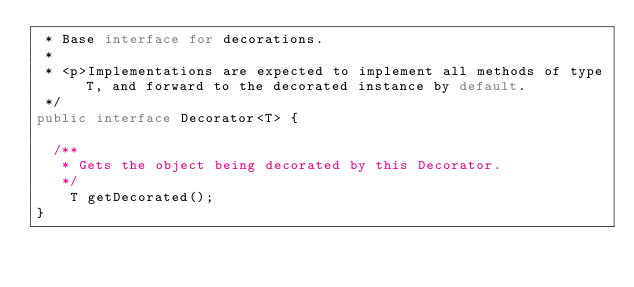Convert code to text. <code><loc_0><loc_0><loc_500><loc_500><_Java_> * Base interface for decorations.
 *
 * <p>Implementations are expected to implement all methods of type T, and forward to the decorated instance by default.
 */
public interface Decorator<T> {
	
	/**
	 * Gets the object being decorated by this Decorator.
	 */
    T getDecorated();
}
</code> 